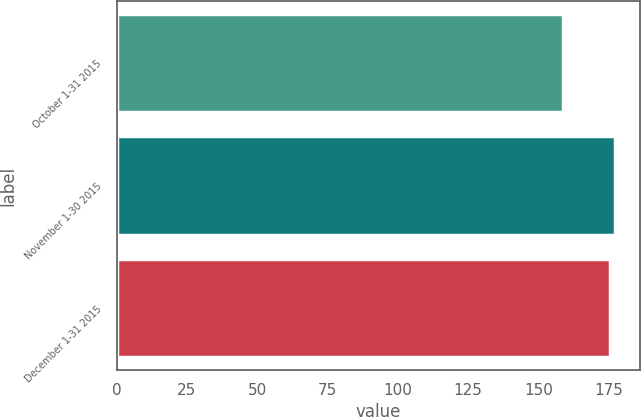Convert chart to OTSL. <chart><loc_0><loc_0><loc_500><loc_500><bar_chart><fcel>October 1-31 2015<fcel>November 1-30 2015<fcel>December 1-31 2015<nl><fcel>158.69<fcel>177.3<fcel>175.59<nl></chart> 